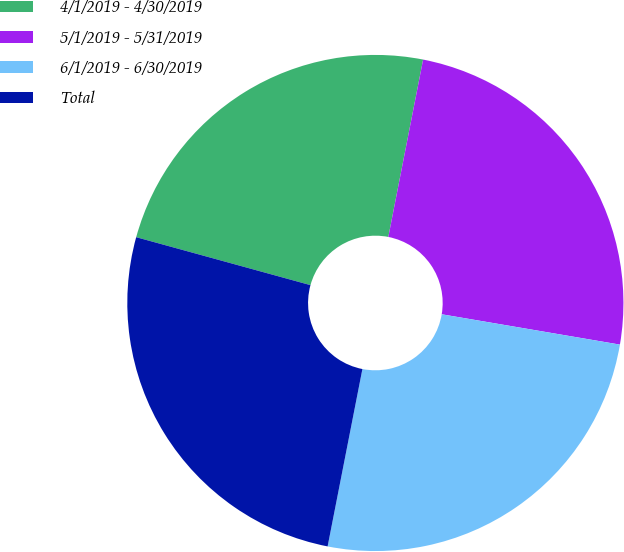Convert chart to OTSL. <chart><loc_0><loc_0><loc_500><loc_500><pie_chart><fcel>4/1/2019 - 4/30/2019<fcel>5/1/2019 - 5/31/2019<fcel>6/1/2019 - 6/30/2019<fcel>Total<nl><fcel>23.81%<fcel>24.6%<fcel>25.4%<fcel>26.19%<nl></chart> 